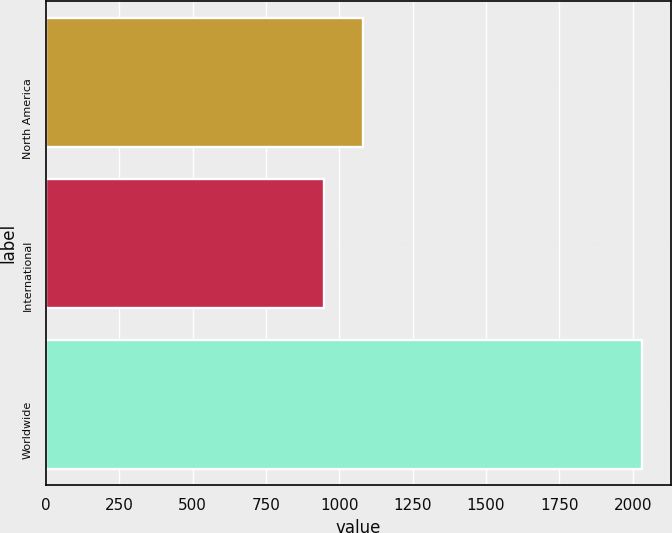<chart> <loc_0><loc_0><loc_500><loc_500><bar_chart><fcel>North America<fcel>International<fcel>Worldwide<nl><fcel>1082<fcel>948<fcel>2030<nl></chart> 